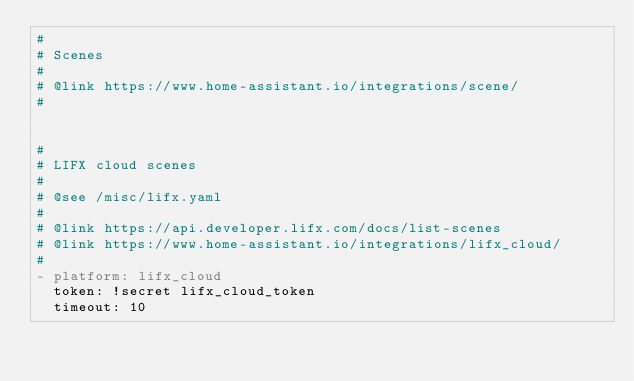<code> <loc_0><loc_0><loc_500><loc_500><_YAML_>#
# Scenes
#
# @link https://www.home-assistant.io/integrations/scene/
#


#
# LIFX cloud scenes
#
# @see /misc/lifx.yaml
#
# @link https://api.developer.lifx.com/docs/list-scenes
# @link https://www.home-assistant.io/integrations/lifx_cloud/
#
- platform: lifx_cloud
  token: !secret lifx_cloud_token
  timeout: 10
</code> 